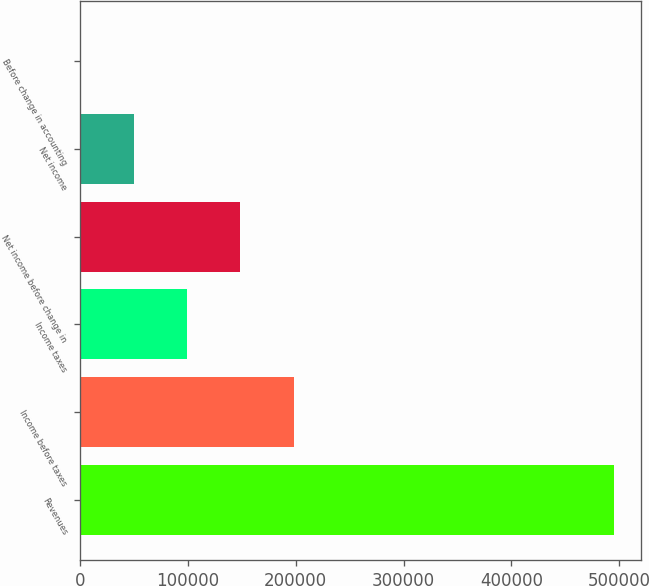Convert chart. <chart><loc_0><loc_0><loc_500><loc_500><bar_chart><fcel>Revenues<fcel>Income before taxes<fcel>Income taxes<fcel>Net income before change in<fcel>Net income<fcel>Before change in accounting<nl><fcel>495384<fcel>198154<fcel>99076.8<fcel>148615<fcel>49538.4<fcel>0.03<nl></chart> 